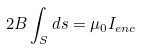Convert formula to latex. <formula><loc_0><loc_0><loc_500><loc_500>2 B \int _ { S } d s = \mu _ { 0 } I _ { e n c }</formula> 